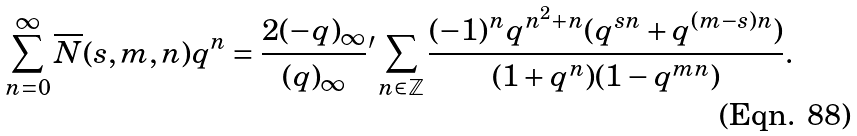<formula> <loc_0><loc_0><loc_500><loc_500>\sum _ { n = 0 } ^ { \infty } \overline { N } ( s , m , n ) q ^ { n } = \frac { 2 ( - q ) _ { \infty } } { ( q ) _ { \infty } } { ^ { \prime } } \sum _ { n \in \mathbb { Z } } \frac { ( - 1 ) ^ { n } q ^ { n ^ { 2 } + n } ( q ^ { s n } + q ^ { ( m - s ) n } ) } { ( 1 + q ^ { n } ) ( 1 - q ^ { m n } ) } .</formula> 